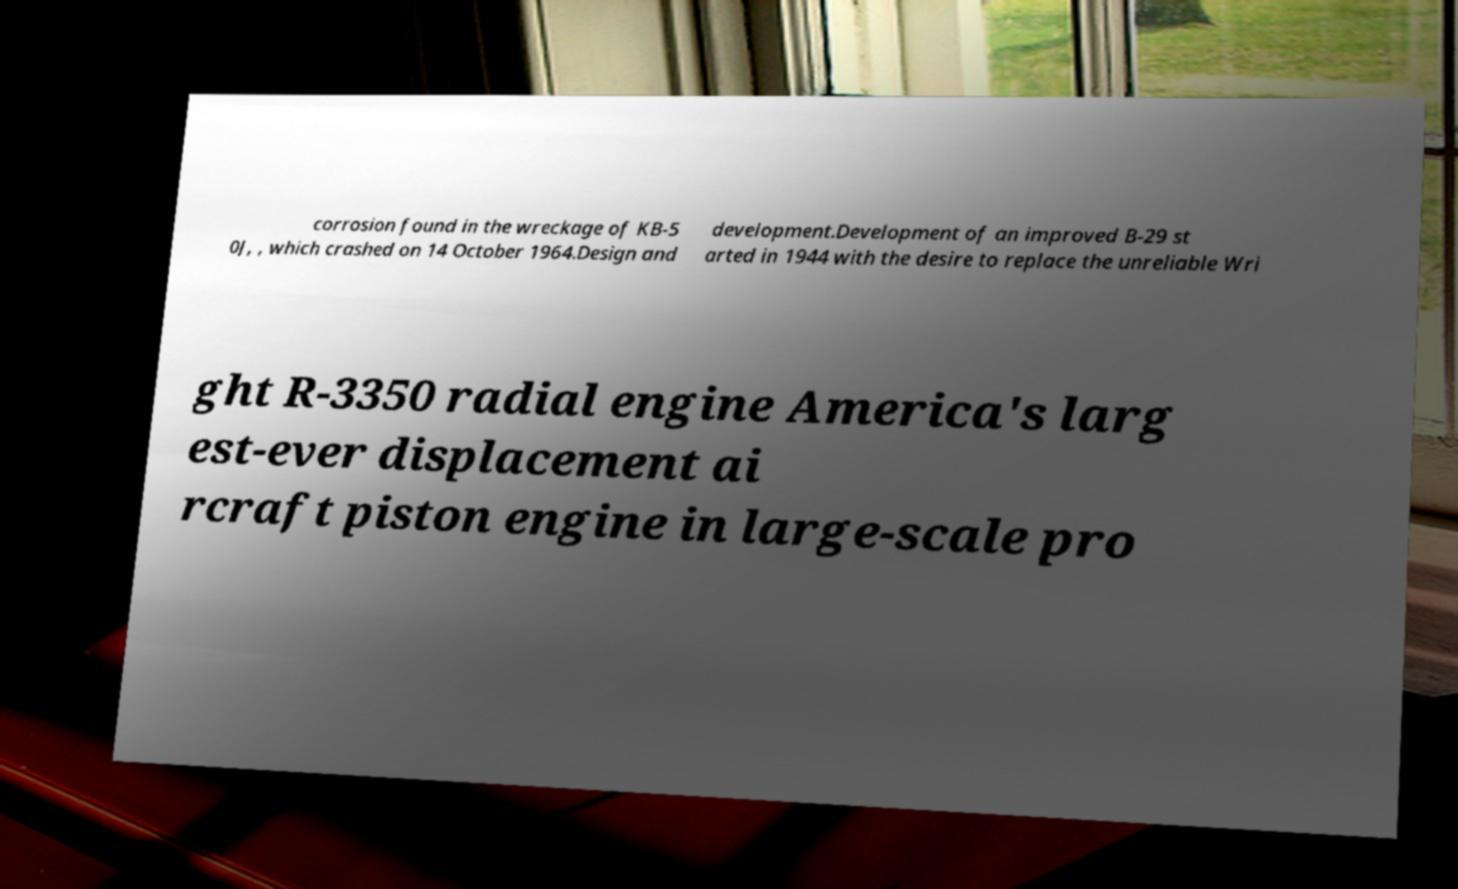Could you extract and type out the text from this image? corrosion found in the wreckage of KB-5 0J, , which crashed on 14 October 1964.Design and development.Development of an improved B-29 st arted in 1944 with the desire to replace the unreliable Wri ght R-3350 radial engine America's larg est-ever displacement ai rcraft piston engine in large-scale pro 